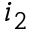Convert formula to latex. <formula><loc_0><loc_0><loc_500><loc_500>i _ { 2 }</formula> 